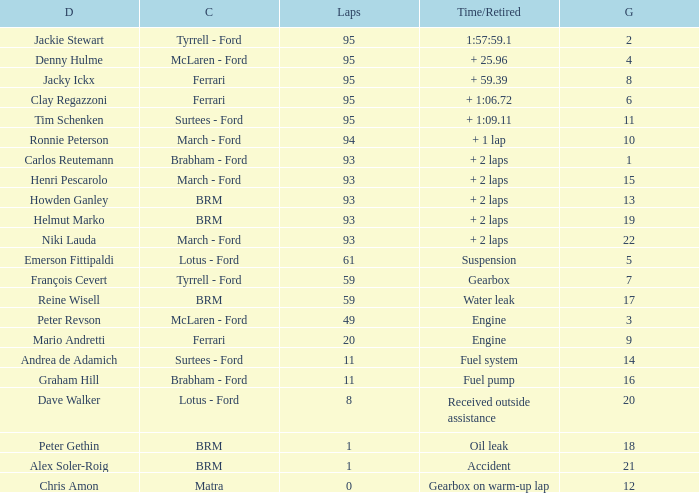What is the largest number of laps with a Grid larger than 14, a Time/Retired of + 2 laps, and a Driver of helmut marko? 93.0. 